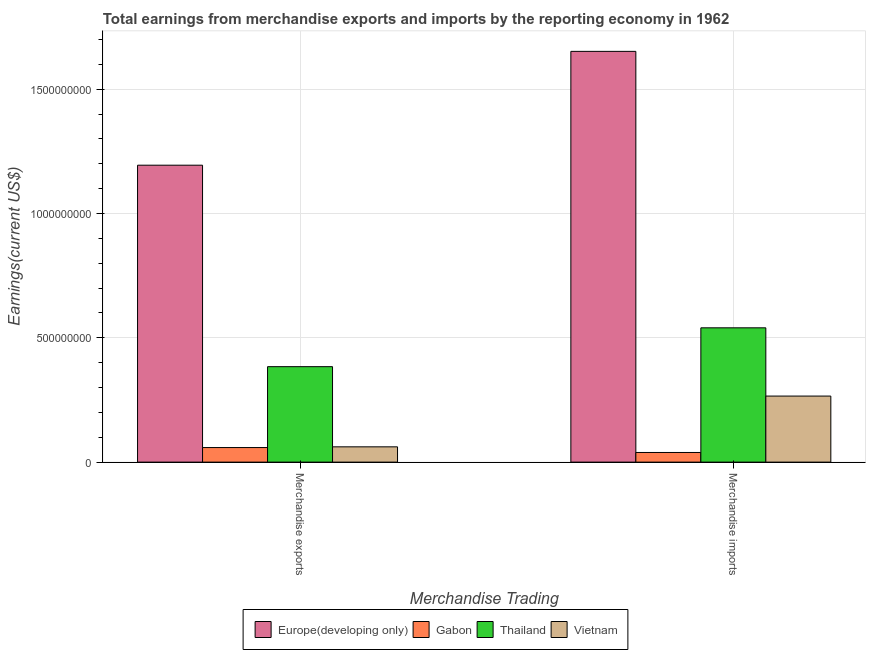Are the number of bars on each tick of the X-axis equal?
Ensure brevity in your answer.  Yes. How many bars are there on the 2nd tick from the left?
Make the answer very short. 4. How many bars are there on the 2nd tick from the right?
Your answer should be compact. 4. What is the earnings from merchandise exports in Vietnam?
Keep it short and to the point. 6.15e+07. Across all countries, what is the maximum earnings from merchandise imports?
Your answer should be very brief. 1.65e+09. Across all countries, what is the minimum earnings from merchandise imports?
Offer a very short reply. 3.88e+07. In which country was the earnings from merchandise exports maximum?
Provide a short and direct response. Europe(developing only). In which country was the earnings from merchandise imports minimum?
Your response must be concise. Gabon. What is the total earnings from merchandise exports in the graph?
Make the answer very short. 1.70e+09. What is the difference between the earnings from merchandise exports in Europe(developing only) and that in Thailand?
Give a very brief answer. 8.10e+08. What is the difference between the earnings from merchandise exports in Europe(developing only) and the earnings from merchandise imports in Gabon?
Your response must be concise. 1.16e+09. What is the average earnings from merchandise exports per country?
Offer a very short reply. 4.25e+08. What is the difference between the earnings from merchandise imports and earnings from merchandise exports in Gabon?
Ensure brevity in your answer.  -1.98e+07. What is the ratio of the earnings from merchandise imports in Gabon to that in Europe(developing only)?
Provide a succinct answer. 0.02. What does the 4th bar from the left in Merchandise imports represents?
Offer a very short reply. Vietnam. What does the 3rd bar from the right in Merchandise exports represents?
Your response must be concise. Gabon. How many bars are there?
Provide a short and direct response. 8. Does the graph contain any zero values?
Your answer should be very brief. No. How are the legend labels stacked?
Ensure brevity in your answer.  Horizontal. What is the title of the graph?
Your response must be concise. Total earnings from merchandise exports and imports by the reporting economy in 1962. Does "Senegal" appear as one of the legend labels in the graph?
Give a very brief answer. No. What is the label or title of the X-axis?
Provide a short and direct response. Merchandise Trading. What is the label or title of the Y-axis?
Provide a succinct answer. Earnings(current US$). What is the Earnings(current US$) in Europe(developing only) in Merchandise exports?
Provide a succinct answer. 1.19e+09. What is the Earnings(current US$) in Gabon in Merchandise exports?
Your answer should be compact. 5.86e+07. What is the Earnings(current US$) in Thailand in Merchandise exports?
Provide a succinct answer. 3.84e+08. What is the Earnings(current US$) of Vietnam in Merchandise exports?
Ensure brevity in your answer.  6.15e+07. What is the Earnings(current US$) of Europe(developing only) in Merchandise imports?
Make the answer very short. 1.65e+09. What is the Earnings(current US$) of Gabon in Merchandise imports?
Give a very brief answer. 3.88e+07. What is the Earnings(current US$) of Thailand in Merchandise imports?
Offer a very short reply. 5.40e+08. What is the Earnings(current US$) in Vietnam in Merchandise imports?
Keep it short and to the point. 2.66e+08. Across all Merchandise Trading, what is the maximum Earnings(current US$) in Europe(developing only)?
Ensure brevity in your answer.  1.65e+09. Across all Merchandise Trading, what is the maximum Earnings(current US$) of Gabon?
Keep it short and to the point. 5.86e+07. Across all Merchandise Trading, what is the maximum Earnings(current US$) of Thailand?
Offer a very short reply. 5.40e+08. Across all Merchandise Trading, what is the maximum Earnings(current US$) in Vietnam?
Provide a succinct answer. 2.66e+08. Across all Merchandise Trading, what is the minimum Earnings(current US$) in Europe(developing only)?
Your response must be concise. 1.19e+09. Across all Merchandise Trading, what is the minimum Earnings(current US$) of Gabon?
Provide a short and direct response. 3.88e+07. Across all Merchandise Trading, what is the minimum Earnings(current US$) in Thailand?
Offer a very short reply. 3.84e+08. Across all Merchandise Trading, what is the minimum Earnings(current US$) in Vietnam?
Offer a terse response. 6.15e+07. What is the total Earnings(current US$) of Europe(developing only) in the graph?
Provide a succinct answer. 2.85e+09. What is the total Earnings(current US$) in Gabon in the graph?
Keep it short and to the point. 9.74e+07. What is the total Earnings(current US$) of Thailand in the graph?
Your answer should be very brief. 9.24e+08. What is the total Earnings(current US$) in Vietnam in the graph?
Your answer should be very brief. 3.27e+08. What is the difference between the Earnings(current US$) in Europe(developing only) in Merchandise exports and that in Merchandise imports?
Offer a terse response. -4.58e+08. What is the difference between the Earnings(current US$) of Gabon in Merchandise exports and that in Merchandise imports?
Ensure brevity in your answer.  1.98e+07. What is the difference between the Earnings(current US$) of Thailand in Merchandise exports and that in Merchandise imports?
Keep it short and to the point. -1.56e+08. What is the difference between the Earnings(current US$) in Vietnam in Merchandise exports and that in Merchandise imports?
Keep it short and to the point. -2.04e+08. What is the difference between the Earnings(current US$) of Europe(developing only) in Merchandise exports and the Earnings(current US$) of Gabon in Merchandise imports?
Offer a terse response. 1.16e+09. What is the difference between the Earnings(current US$) in Europe(developing only) in Merchandise exports and the Earnings(current US$) in Thailand in Merchandise imports?
Provide a short and direct response. 6.54e+08. What is the difference between the Earnings(current US$) of Europe(developing only) in Merchandise exports and the Earnings(current US$) of Vietnam in Merchandise imports?
Your answer should be compact. 9.28e+08. What is the difference between the Earnings(current US$) in Gabon in Merchandise exports and the Earnings(current US$) in Thailand in Merchandise imports?
Offer a very short reply. -4.82e+08. What is the difference between the Earnings(current US$) of Gabon in Merchandise exports and the Earnings(current US$) of Vietnam in Merchandise imports?
Your answer should be very brief. -2.07e+08. What is the difference between the Earnings(current US$) in Thailand in Merchandise exports and the Earnings(current US$) in Vietnam in Merchandise imports?
Offer a terse response. 1.18e+08. What is the average Earnings(current US$) in Europe(developing only) per Merchandise Trading?
Provide a succinct answer. 1.42e+09. What is the average Earnings(current US$) in Gabon per Merchandise Trading?
Keep it short and to the point. 4.87e+07. What is the average Earnings(current US$) of Thailand per Merchandise Trading?
Offer a terse response. 4.62e+08. What is the average Earnings(current US$) in Vietnam per Merchandise Trading?
Give a very brief answer. 1.64e+08. What is the difference between the Earnings(current US$) in Europe(developing only) and Earnings(current US$) in Gabon in Merchandise exports?
Ensure brevity in your answer.  1.14e+09. What is the difference between the Earnings(current US$) of Europe(developing only) and Earnings(current US$) of Thailand in Merchandise exports?
Your response must be concise. 8.10e+08. What is the difference between the Earnings(current US$) in Europe(developing only) and Earnings(current US$) in Vietnam in Merchandise exports?
Your response must be concise. 1.13e+09. What is the difference between the Earnings(current US$) of Gabon and Earnings(current US$) of Thailand in Merchandise exports?
Give a very brief answer. -3.25e+08. What is the difference between the Earnings(current US$) of Gabon and Earnings(current US$) of Vietnam in Merchandise exports?
Give a very brief answer. -2.91e+06. What is the difference between the Earnings(current US$) of Thailand and Earnings(current US$) of Vietnam in Merchandise exports?
Provide a short and direct response. 3.22e+08. What is the difference between the Earnings(current US$) of Europe(developing only) and Earnings(current US$) of Gabon in Merchandise imports?
Offer a terse response. 1.61e+09. What is the difference between the Earnings(current US$) in Europe(developing only) and Earnings(current US$) in Thailand in Merchandise imports?
Keep it short and to the point. 1.11e+09. What is the difference between the Earnings(current US$) of Europe(developing only) and Earnings(current US$) of Vietnam in Merchandise imports?
Make the answer very short. 1.39e+09. What is the difference between the Earnings(current US$) in Gabon and Earnings(current US$) in Thailand in Merchandise imports?
Provide a short and direct response. -5.01e+08. What is the difference between the Earnings(current US$) in Gabon and Earnings(current US$) in Vietnam in Merchandise imports?
Keep it short and to the point. -2.27e+08. What is the difference between the Earnings(current US$) of Thailand and Earnings(current US$) of Vietnam in Merchandise imports?
Your answer should be very brief. 2.74e+08. What is the ratio of the Earnings(current US$) of Europe(developing only) in Merchandise exports to that in Merchandise imports?
Offer a very short reply. 0.72. What is the ratio of the Earnings(current US$) of Gabon in Merchandise exports to that in Merchandise imports?
Your answer should be very brief. 1.51. What is the ratio of the Earnings(current US$) of Thailand in Merchandise exports to that in Merchandise imports?
Offer a very short reply. 0.71. What is the ratio of the Earnings(current US$) in Vietnam in Merchandise exports to that in Merchandise imports?
Offer a very short reply. 0.23. What is the difference between the highest and the second highest Earnings(current US$) in Europe(developing only)?
Offer a terse response. 4.58e+08. What is the difference between the highest and the second highest Earnings(current US$) of Gabon?
Provide a short and direct response. 1.98e+07. What is the difference between the highest and the second highest Earnings(current US$) in Thailand?
Ensure brevity in your answer.  1.56e+08. What is the difference between the highest and the second highest Earnings(current US$) of Vietnam?
Your answer should be very brief. 2.04e+08. What is the difference between the highest and the lowest Earnings(current US$) in Europe(developing only)?
Your answer should be compact. 4.58e+08. What is the difference between the highest and the lowest Earnings(current US$) in Gabon?
Ensure brevity in your answer.  1.98e+07. What is the difference between the highest and the lowest Earnings(current US$) of Thailand?
Offer a terse response. 1.56e+08. What is the difference between the highest and the lowest Earnings(current US$) of Vietnam?
Your response must be concise. 2.04e+08. 